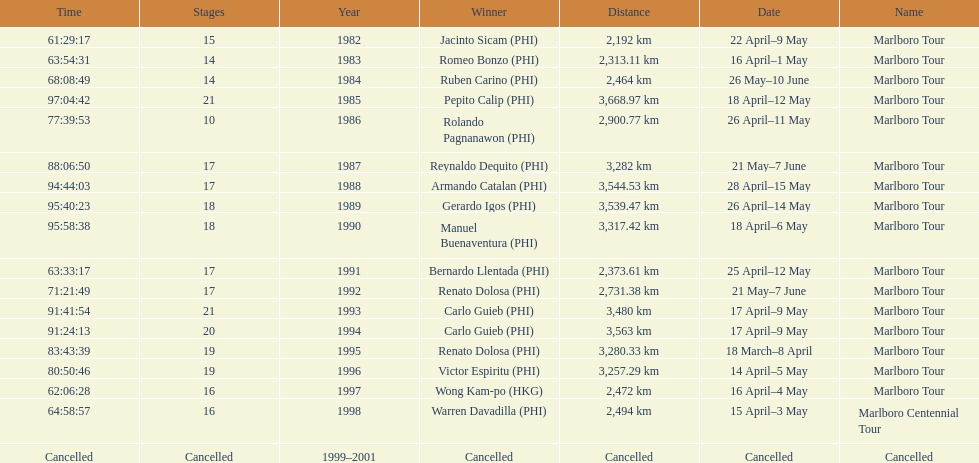How long did it take warren davadilla to complete the 1998 marlboro centennial tour? 64:58:57. 